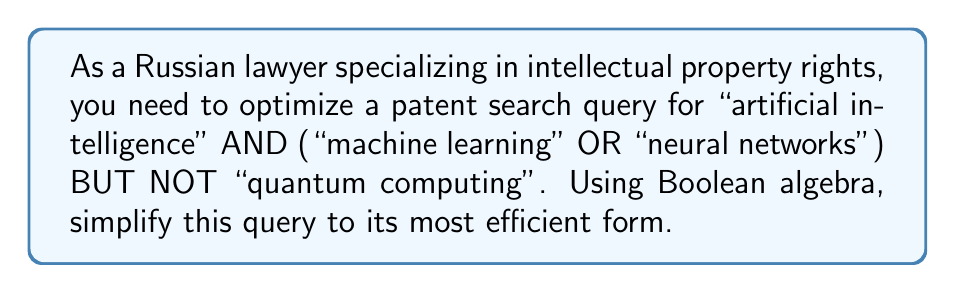Show me your answer to this math problem. Let's approach this step-by-step using Boolean algebra:

1) First, let's assign variables to each term:
   A = "artificial intelligence"
   B = "machine learning"
   C = "neural networks"
   D = "quantum computing"

2) The original query in Boolean terms is:
   $$ A \land (B \lor C) \land \lnot D $$

3) This expression is already in a simplified form, but we can rearrange it to make it more efficient for database searches:

4) Using the associative property of AND ($\land$), we can rewrite it as:
   $$ (A \land (B \lor C)) \land \lnot D $$

5) Now, using the distributive property of AND over OR, we can expand this to:
   $$ ((A \land B) \lor (A \land C)) \land \lnot D $$

6) This form allows for more efficient searching in many patent databases, as it breaks down the query into two main parts that can be processed separately and then combined.

7) The final optimized query in Boolean algebra notation is:
   $$ ((A \land B) \lor (A \land C)) \land \lnot D $$

This form is logically equivalent to the original query but may be more efficient for database processing.
Answer: $((A \land B) \lor (A \land C)) \land \lnot D$ 